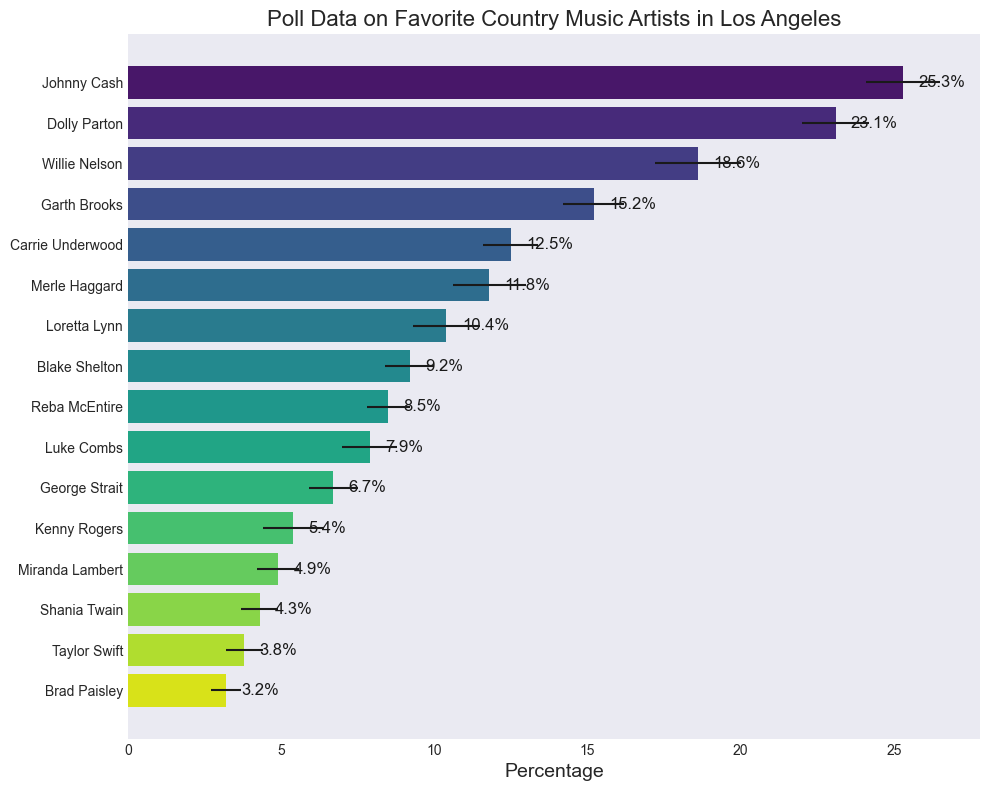Which artist has the highest percentage of favorites? The figure shows a horizontal bar chart with artists on the y-axis and the percentage of favorites on the x-axis. The longest bar represents the highest percentage.
Answer: Johnny Cash Which artist has the smallest margin of error? The figure shows bars with error bars indicating the margin of error. The artist with the shortest error bar has the smallest margin of error.
Answer: Brad Paisley What is the sum of the percentages for Johnny Cash and Dolly Parton? From the figure, Johnny Cash has a percentage of 25.3% and Dolly Parton has 23.1%. Summing these gives 25.3% + 23.1% = 48.4%.
Answer: 48.4% Are there any artists with equal percentages of favorites? The figure shows bars representing the percentages of favorites. Visually comparing the lengths of these bars, none of them are equal.
Answer: No Which artists have a percentage of favorites less than 10% but more than 5%? The artists with bars of length representing percentages between 5% and 10% should be identified.
Answer: Blake Shelton, Reba McEntire, Luke Combs, George Strait, Kenny Rogers What is the average percentage of favorites for the top 3 artists? The top three artists by percentage are Johnny Cash, Dolly Parton, and Willie Nelson with percentages of 25.3%, 23.1%, and 18.6%. The average is calculated as (25.3 + 23.1 + 18.6) / 3 = 22.33%.
Answer: 22.33% How much higher is Johnny Cash's percentage compared to Carrie Underwood's? Johnny Cash's percentage is 25.3% and Carrie Underwood's is 12.5%. The difference is 25.3% - 12.5% = 12.8%.
Answer: 12.8% Which artist has the highest margin of error, and what is it? By observing the length of the error bars, Willie Nelson's error bar is the longest, indicating the highest margin of error, which is 1.4%.
Answer: Willie Nelson, 1.4% What is the sum of percentages for all artists having a margin of error greater than 1%? Artists with a margin of error greater than 1% are Johnny Cash, Willie Nelson, Merle Haggard, and Kenny Rogers with percentages of 25.3%, 18.6%, 11.8%, and 5.4%. Summing these gives 25.3% + 18.6% + 11.8% + 5.4% = 61.1%.
Answer: 61.1% Among Dolly Parton, Blake Shelton, and Taylor Swift, who has the lowest percentage of favorites? Comparing the percentages visually, Dolly Parton has 23.1%, Blake Shelton has 9.2%, and Taylor Swift has 3.8%. Taylor Swift has the lowest percentage.
Answer: Taylor Swift 